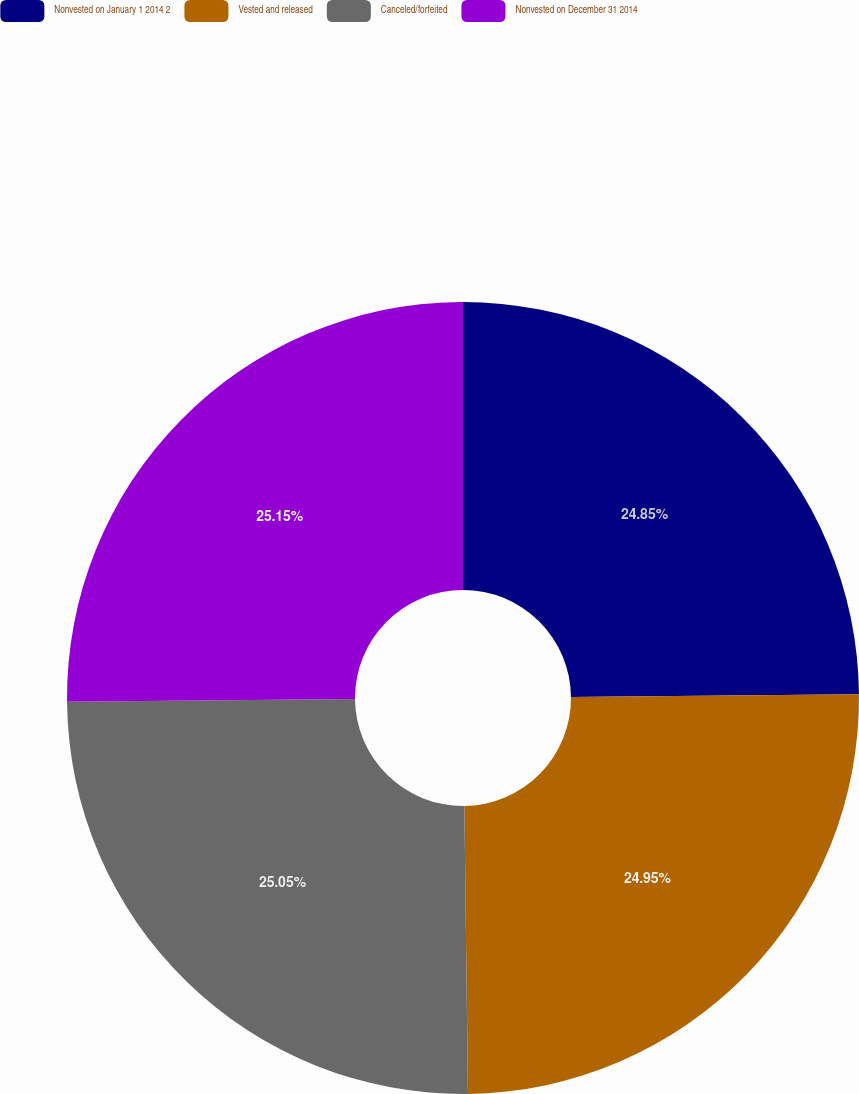<chart> <loc_0><loc_0><loc_500><loc_500><pie_chart><fcel>Nonvested on January 1 2014 2<fcel>Vested and released<fcel>Canceled/forfeited<fcel>Nonvested on December 31 2014<nl><fcel>24.85%<fcel>24.95%<fcel>25.05%<fcel>25.15%<nl></chart> 